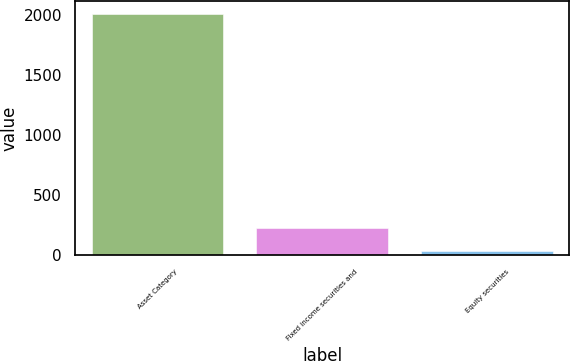Convert chart to OTSL. <chart><loc_0><loc_0><loc_500><loc_500><bar_chart><fcel>Asset Category<fcel>Fixed income securities and<fcel>Equity securities<nl><fcel>2015<fcel>228.5<fcel>30<nl></chart> 